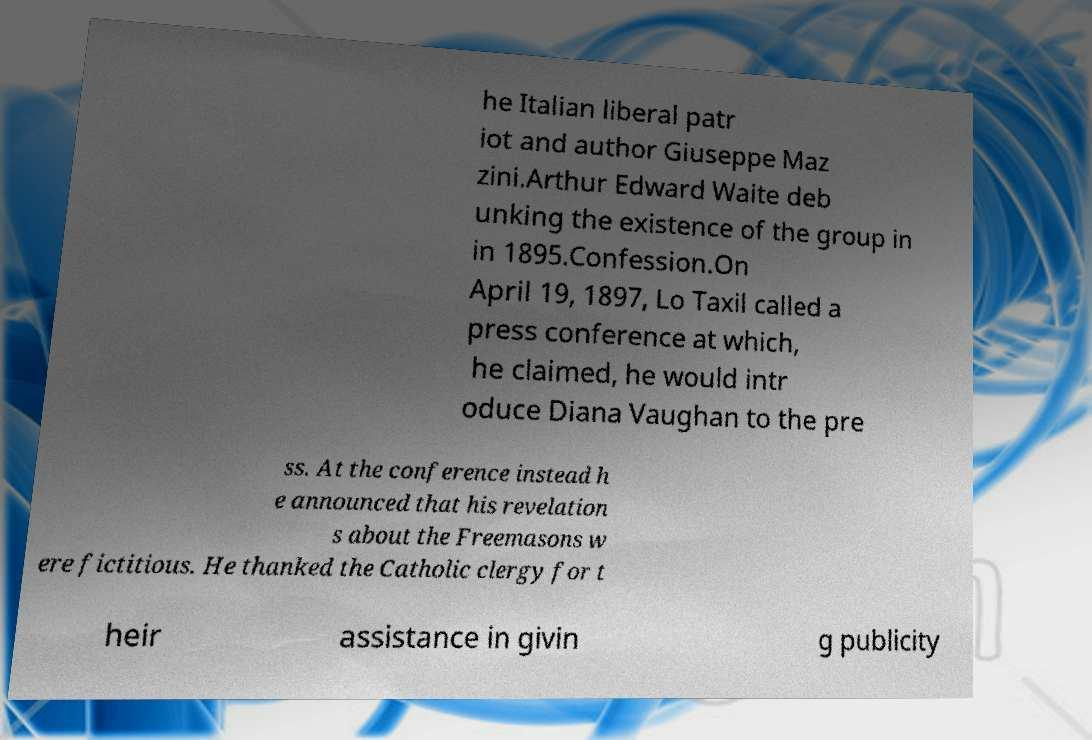I need the written content from this picture converted into text. Can you do that? he Italian liberal patr iot and author Giuseppe Maz zini.Arthur Edward Waite deb unking the existence of the group in in 1895.Confession.On April 19, 1897, Lo Taxil called a press conference at which, he claimed, he would intr oduce Diana Vaughan to the pre ss. At the conference instead h e announced that his revelation s about the Freemasons w ere fictitious. He thanked the Catholic clergy for t heir assistance in givin g publicity 